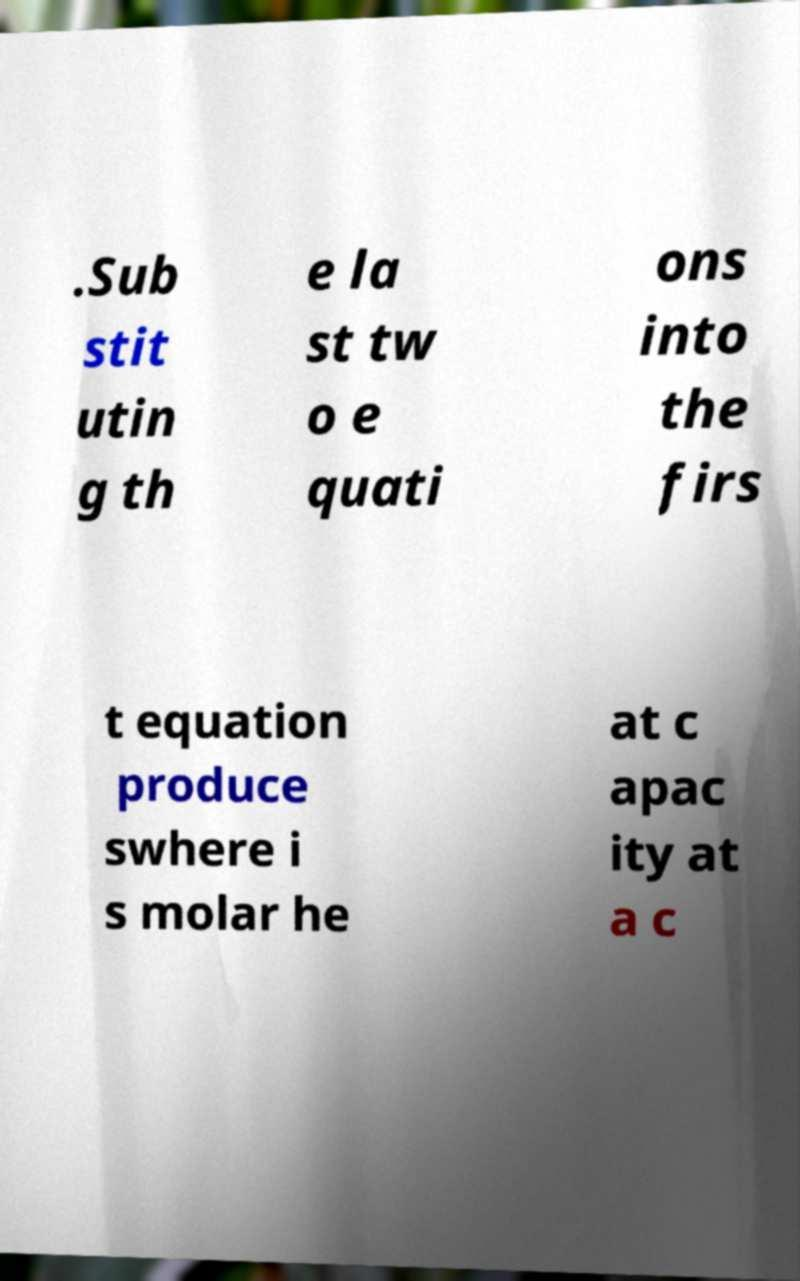Please read and relay the text visible in this image. What does it say? .Sub stit utin g th e la st tw o e quati ons into the firs t equation produce swhere i s molar he at c apac ity at a c 